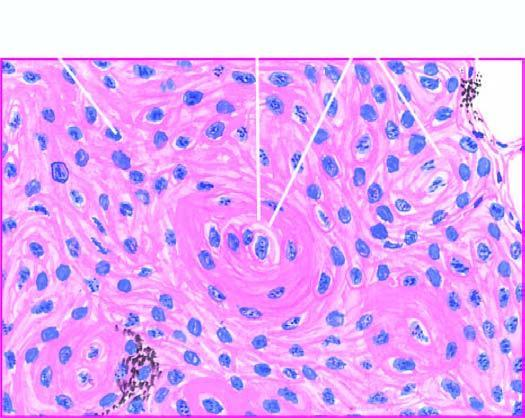what are a few well-developed cell nests with?
Answer the question using a single word or phrase. Keratinisation 